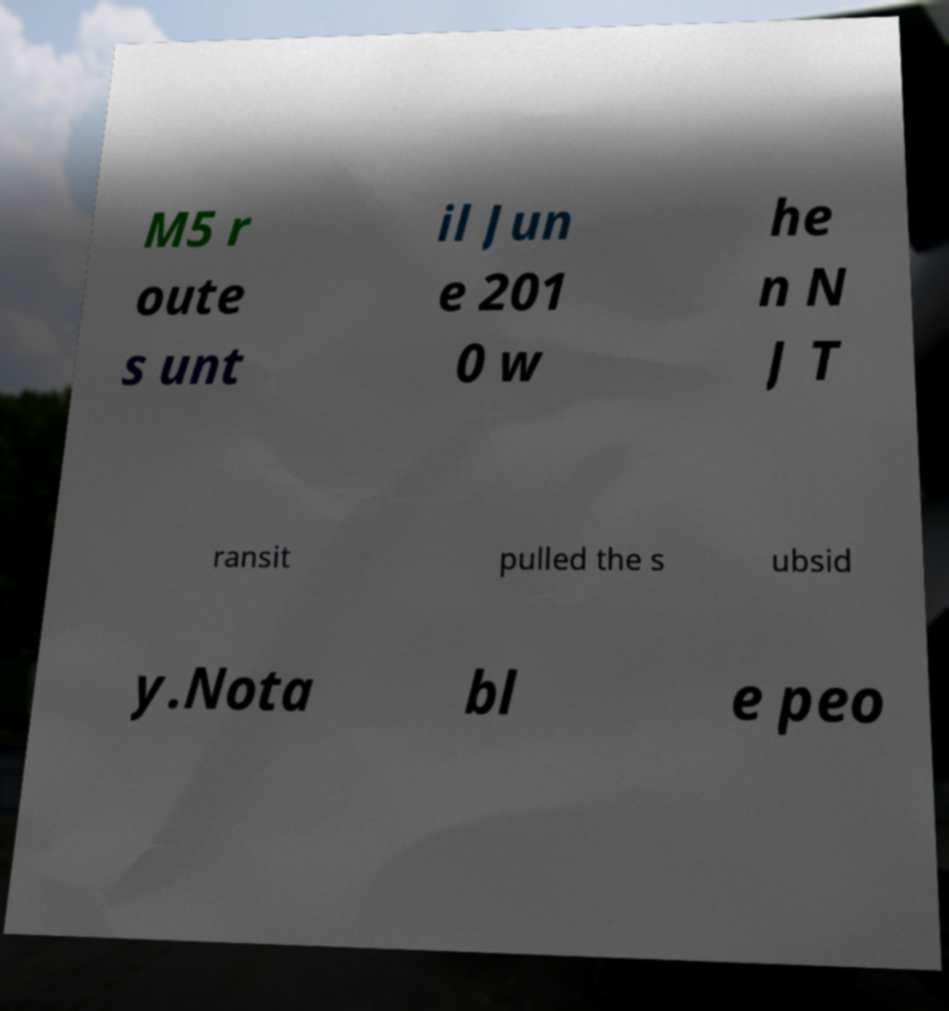I need the written content from this picture converted into text. Can you do that? M5 r oute s unt il Jun e 201 0 w he n N J T ransit pulled the s ubsid y.Nota bl e peo 